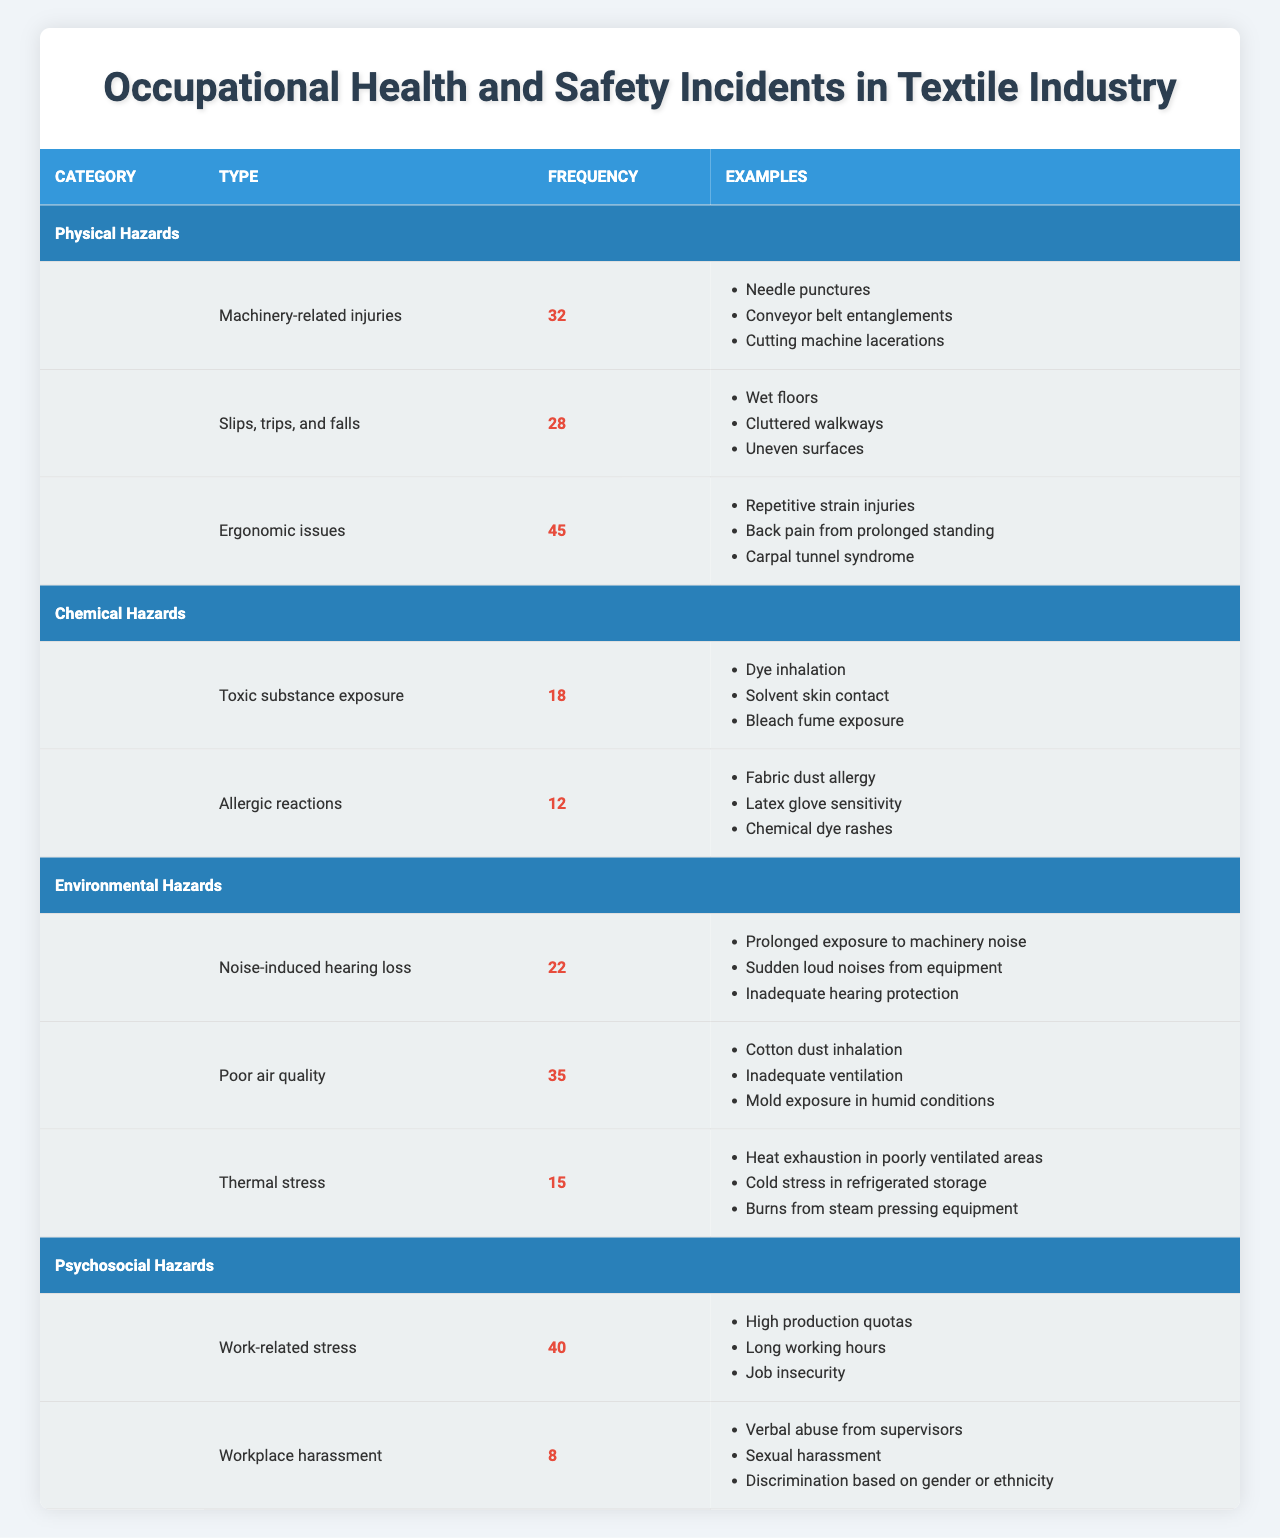What is the most frequent type of ergonomic issue reported? The table shows that "Ergonomic issues" has a frequency of 45, which is the highest among all subcategories in the physical hazards category.
Answer: Ergonomic issues How many total incidents are reported in the category of physical hazards? The table lists three types under physical hazards: machinery-related injuries (32), slips, trips, and falls (28), and ergonomic issues (45). Adding these frequencies gives us 32 + 28 + 45 = 105.
Answer: 105 Which category has the least reported incidents? Looking at the frequencies across all categories, the data shows that "Workplace harassment" under psychosocial hazards has the lowest frequency at 8 incidents compared to others.
Answer: Psychosocial hazards What percentage of incidents in the chemical hazards category are due to allergic reactions? The chemical hazards category has a total of 30 incidents (toxic substance exposure 18 + allergic reactions 12). The allergic reactions frequency is 12. To find the percentage, calculate (12/30) * 100, which equals 40%.
Answer: 40% Is the total number of incidents for environmental hazards greater than that of physical hazards? The frequency of environmental hazards totals 72 (noise-induced hearing loss 22 + poor air quality 35 + thermal stress 15 = 72). The physical hazards total is 105. Comparing these, 72 is less than 105.
Answer: No What is the average frequency of incidents across all categories? Adding up all the frequencies from each category gives 32 + 28 + 45 + 18 + 12 + 22 + 35 + 15 + 40 + 8 =  315. There are 4 categories. The average frequency is calculated as 315 divided by 4, which equals 78.75.
Answer: 78.75 Are there more incidents classified as environmental hazards than as psychosocial hazards? The environmental hazards category has a total of 72 incidents while the psychosocial hazards category has a total of 48 incidents (40 for work-related stress and 8 for workplace harassment). Since 72 is greater than 48, the answer is evident.
Answer: Yes What specific examples are associated with the highest frequency ergonomic issue? The highest frequency among ergonomic issues is 45, which includes examples like "Repetitive strain injuries," "Back pain from prolonged standing," and "Carpal tunnel syndrome."
Answer: Repetitive strain injuries, Back pain from prolonged standing, Carpal tunnel syndrome What is the frequency of incidents due to toxic substance exposure compared to work-related stress? The frequency for toxic substance exposure is 18, and for work-related stress, it is 40. Since 18 is less than 40, we can confirm this comparison.
Answer: Toxic substance exposure is less frequent 